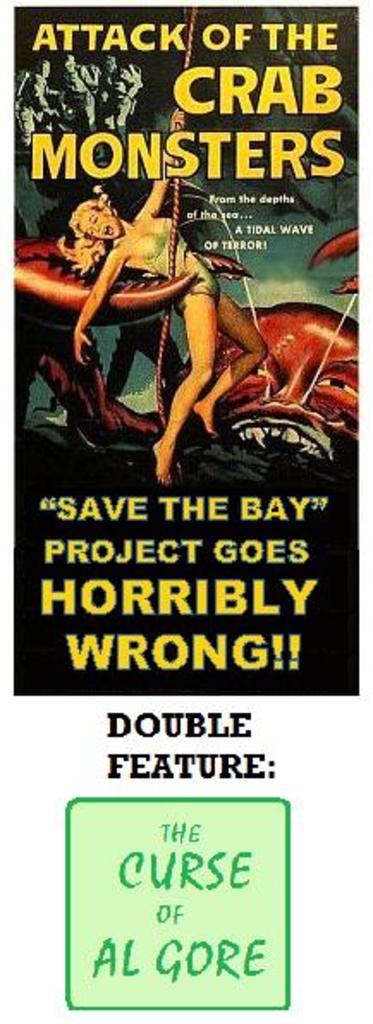What are attacking?
Keep it short and to the point. Crab monsters. Whose curse is mentioned on the book?
Your response must be concise. Al gore. 